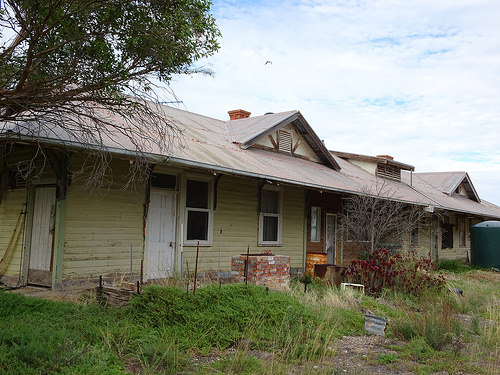<image>
Is the house in front of the grass? Yes. The house is positioned in front of the grass, appearing closer to the camera viewpoint. 